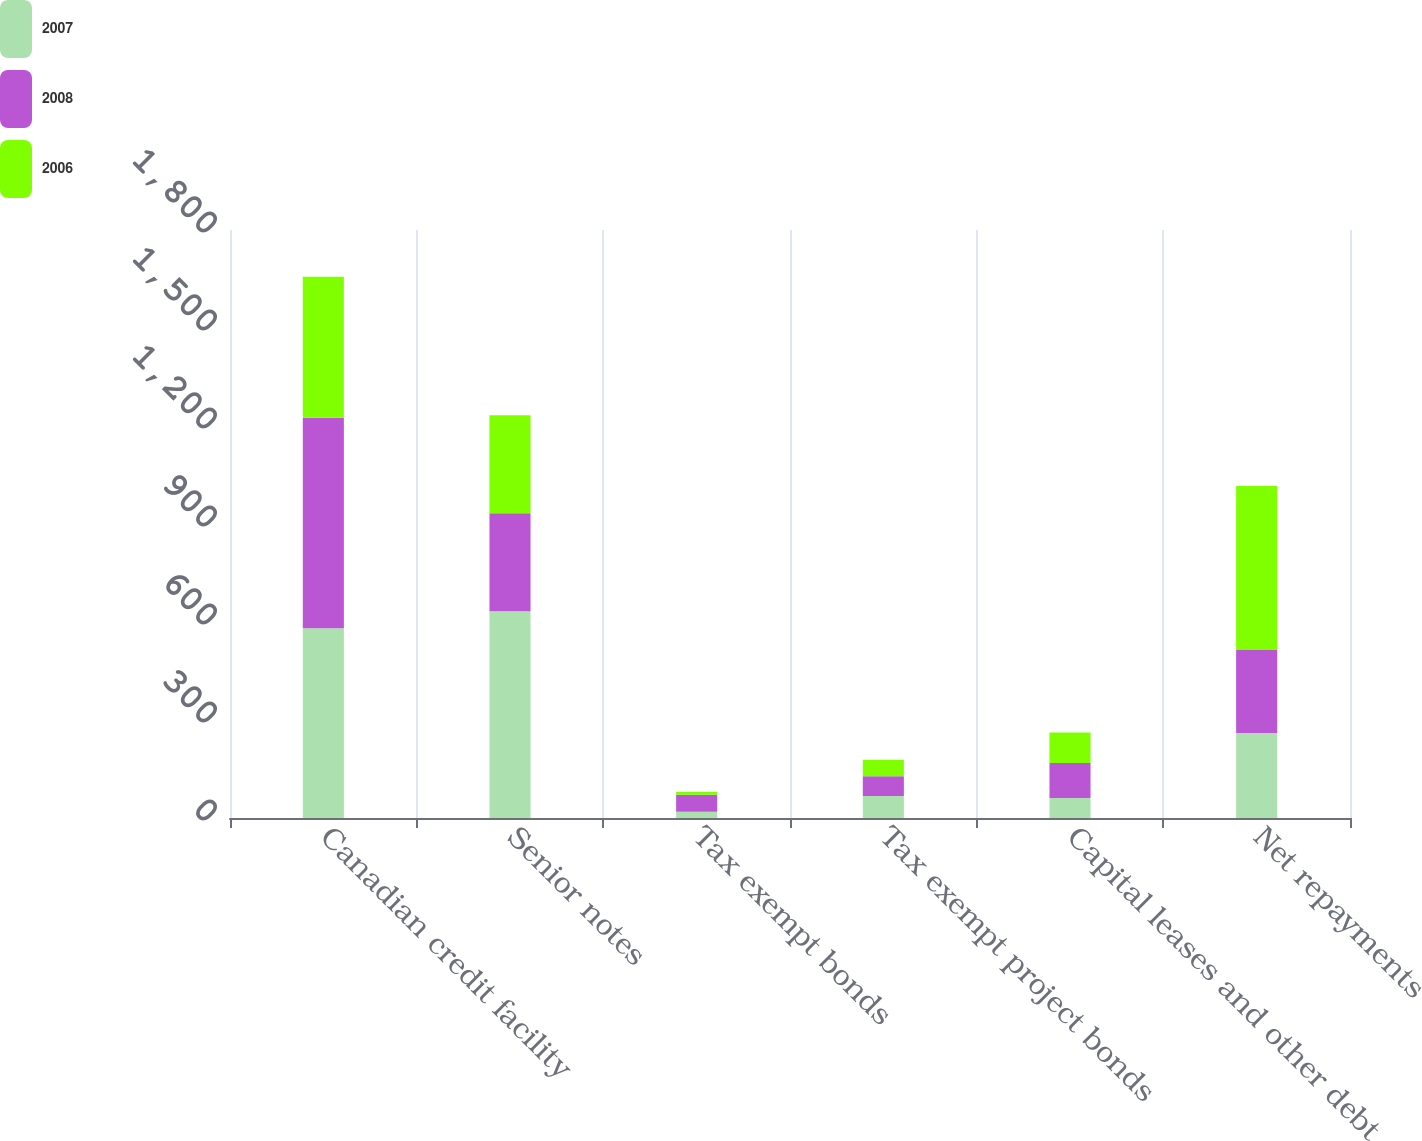<chart> <loc_0><loc_0><loc_500><loc_500><stacked_bar_chart><ecel><fcel>Canadian credit facility<fcel>Senior notes<fcel>Tax exempt bonds<fcel>Tax exempt project bonds<fcel>Capital leases and other debt<fcel>Net repayments<nl><fcel>2007<fcel>581<fcel>633<fcel>19<fcel>67<fcel>61<fcel>260<nl><fcel>2008<fcel>644<fcel>300<fcel>52<fcel>61<fcel>107<fcel>256<nl><fcel>2006<fcel>432<fcel>300<fcel>9<fcel>50<fcel>94<fcel>500<nl></chart> 